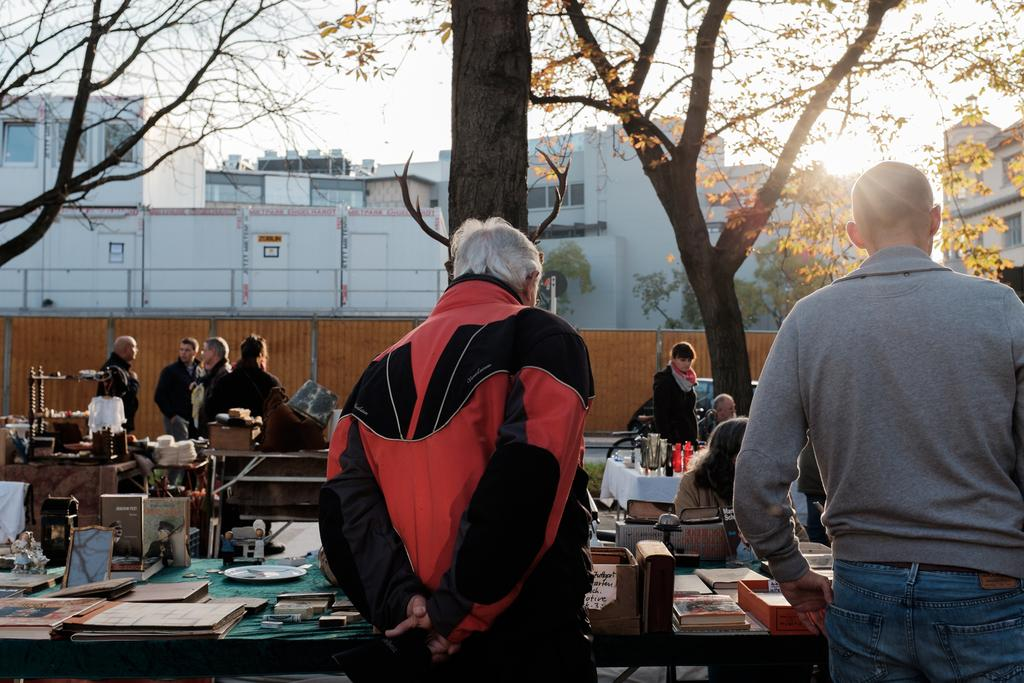What can be seen in the sky in the image? There is a sky in the image, but no specific details are provided about its appearance. What type of natural elements are present in the image? There are trees in the image. What type of man-made structures can be seen in the image? There are buildings in the image. Are there any people present in the image? Yes, there are people in the image. What type of furniture is visible in the image? There is a table in the image. What is placed on the table in the image? There is a plate on the table, as well as photo frames and glasses. How many trains can be seen in the image? There are no trains present in the image. What type of neck accessory is worn by the people in the image? The provided facts do not mention any neck accessories worn by the people in the image. 